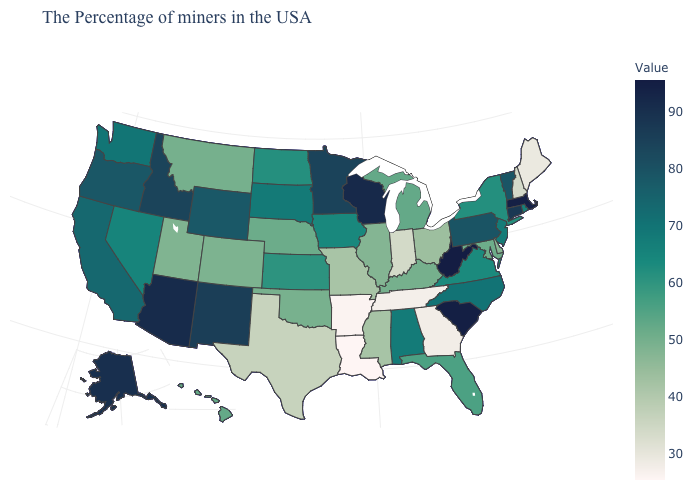Does Maine have the lowest value in the USA?
Be succinct. No. Which states have the lowest value in the MidWest?
Be succinct. Indiana. Does the map have missing data?
Concise answer only. No. Which states have the lowest value in the USA?
Be succinct. Louisiana. Which states hav the highest value in the South?
Be succinct. West Virginia. Does Arizona have the highest value in the West?
Keep it brief. Yes. 